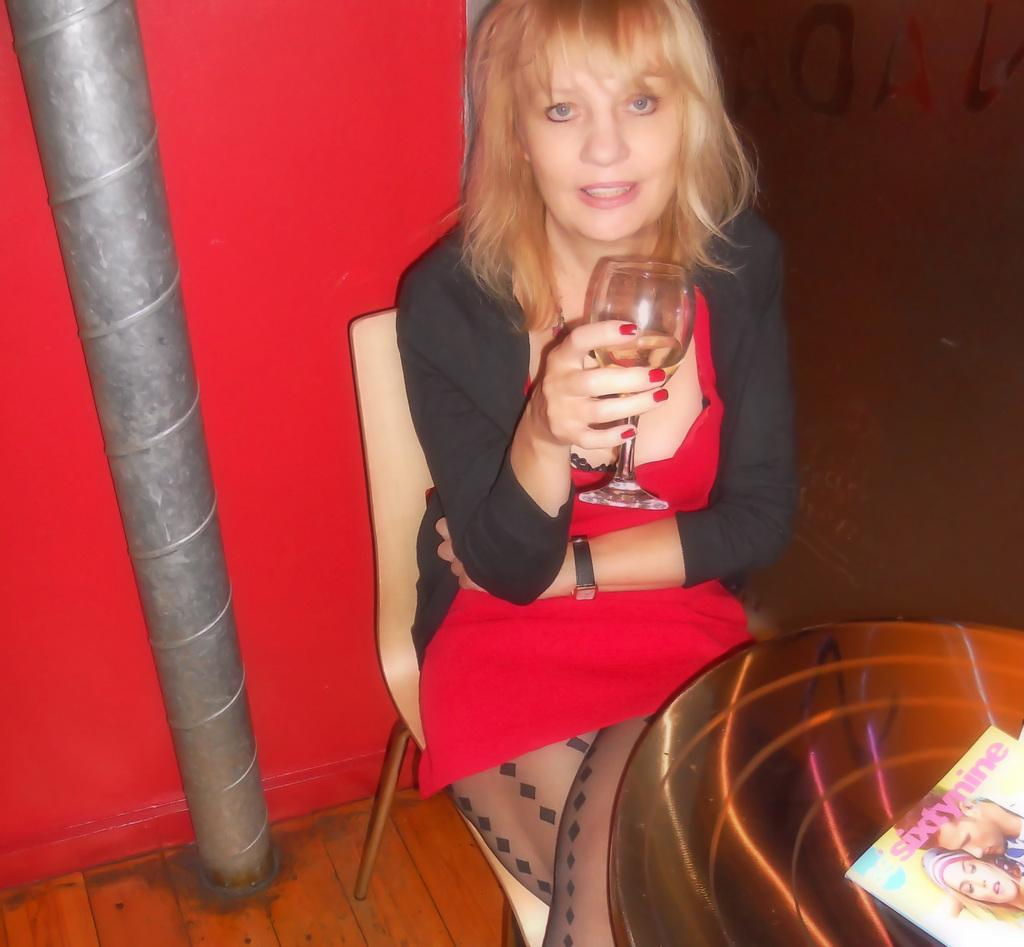Who is present in the image? There is a woman in the image. What is the woman doing in the image? The woman is sitting on a chair. What is the woman holding in the image? The woman is holding a glass. What is in front of the woman in the image? There is a table in front of the woman. What is on the table in the image? There is a photo on paper on the table. What can be seen in the background of the image? There is a wall and a pipe in the background of the image. How many ants can be seen crawling on the woman's face in the image? There are no ants present in the image, and the woman's face is not visible. 